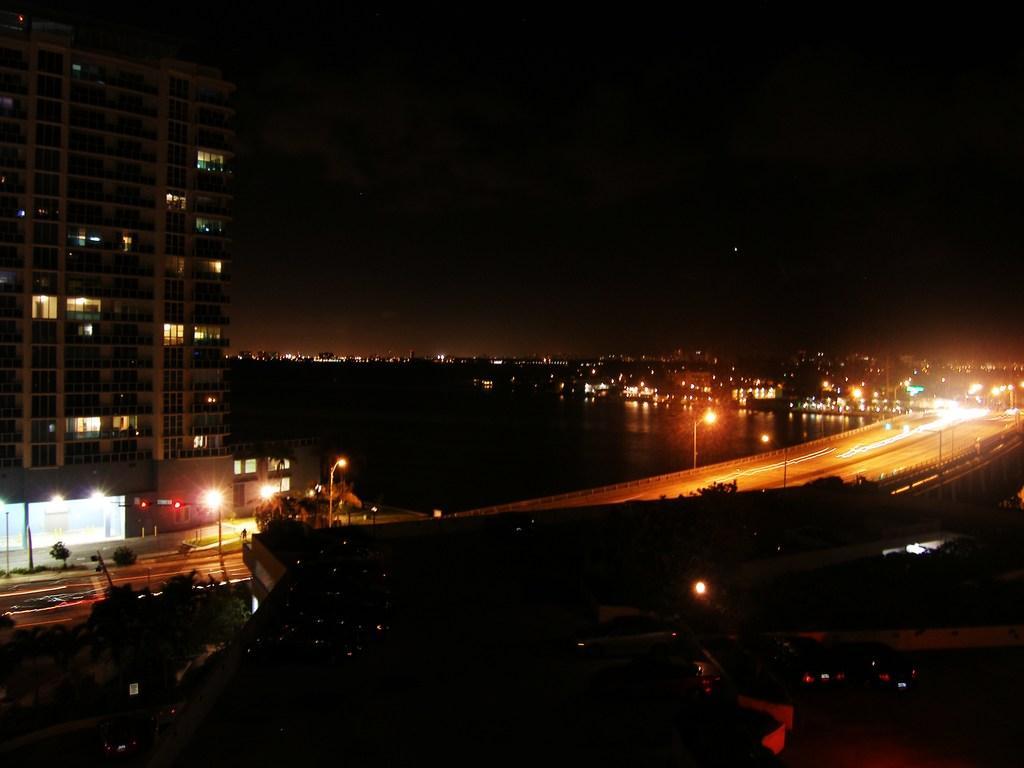Can you describe this image briefly? In this image we can see buildings, street lights, street poles, road, water, trees, bushes and motor vehicles. 